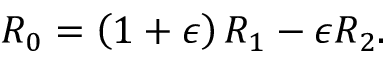Convert formula to latex. <formula><loc_0><loc_0><loc_500><loc_500>\begin{array} { r } { R _ { 0 } = \left ( 1 + \epsilon \right ) R _ { 1 } - \epsilon R _ { 2 } . } \end{array}</formula> 